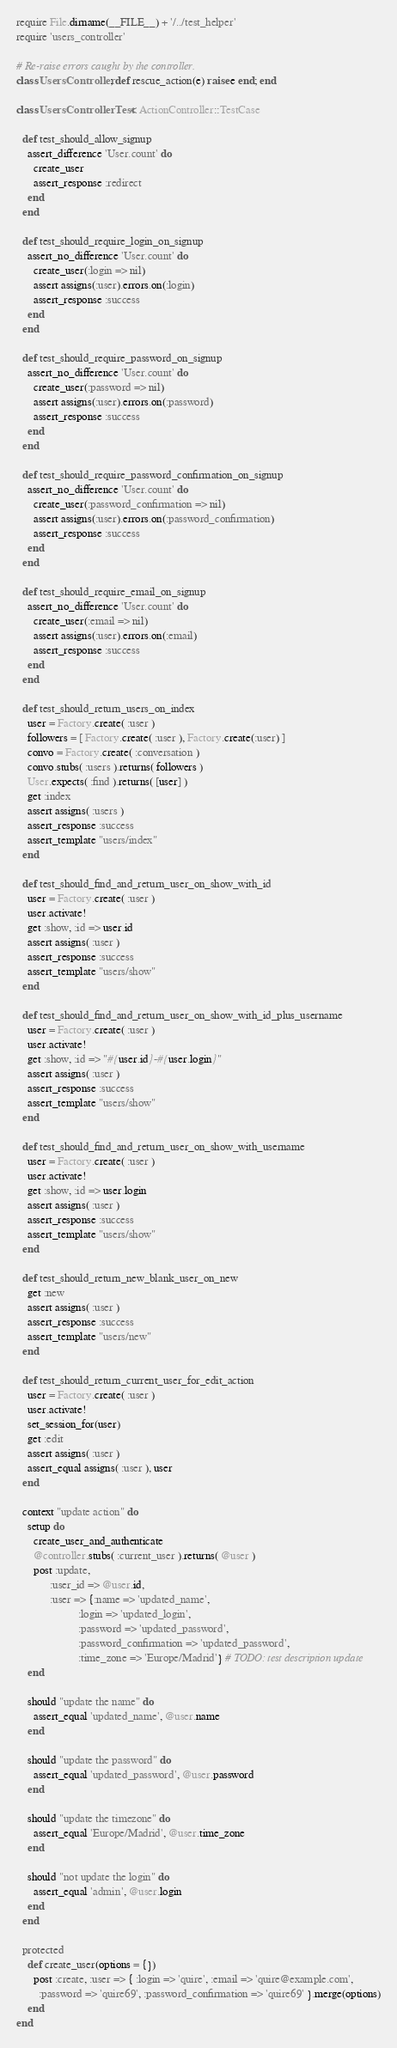Convert code to text. <code><loc_0><loc_0><loc_500><loc_500><_Ruby_>require File.dirname(__FILE__) + '/../test_helper'
require 'users_controller'

# Re-raise errors caught by the controller.
class UsersController; def rescue_action(e) raise e end; end

class UsersControllerTest < ActionController::TestCase

  def test_should_allow_signup
    assert_difference 'User.count' do
      create_user
      assert_response :redirect
    end
  end

  def test_should_require_login_on_signup
    assert_no_difference 'User.count' do
      create_user(:login => nil)
      assert assigns(:user).errors.on(:login)
      assert_response :success
    end
  end

  def test_should_require_password_on_signup
    assert_no_difference 'User.count' do
      create_user(:password => nil)
      assert assigns(:user).errors.on(:password)
      assert_response :success
    end
  end

  def test_should_require_password_confirmation_on_signup
    assert_no_difference 'User.count' do
      create_user(:password_confirmation => nil)
      assert assigns(:user).errors.on(:password_confirmation)
      assert_response :success
    end
  end

  def test_should_require_email_on_signup
    assert_no_difference 'User.count' do
      create_user(:email => nil)
      assert assigns(:user).errors.on(:email)
      assert_response :success
    end
  end
  
  def test_should_return_users_on_index
    user = Factory.create( :user )
    followers = [ Factory.create( :user ), Factory.create(:user) ]
    convo = Factory.create( :conversation )
    convo.stubs( :users ).returns( followers )
    User.expects( :find ).returns( [user] )
    get :index
    assert assigns( :users )
    assert_response :success
    assert_template "users/index"
  end 

  def test_should_find_and_return_user_on_show_with_id
    user = Factory.create( :user )
    user.activate!    
    get :show, :id => user.id
    assert assigns( :user )
    assert_response :success
    assert_template "users/show"
  end
  
  def test_should_find_and_return_user_on_show_with_id_plus_username
    user = Factory.create( :user )
    user.activate!    
    get :show, :id => "#{user.id}-#{user.login}"
    assert assigns( :user )
    assert_response :success
    assert_template "users/show"
  end
  
  def test_should_find_and_return_user_on_show_with_username
    user = Factory.create( :user )
    user.activate!    
    get :show, :id => user.login
    assert assigns( :user )
    assert_response :success
    assert_template "users/show"
  end
  
  def test_should_return_new_blank_user_on_new 
    get :new
    assert assigns( :user )
    assert_response :success
    assert_template "users/new"
  end

  def test_should_return_current_user_for_edit_action
    user = Factory.create( :user )
    user.activate!
    set_session_for(user)
    get :edit
    assert assigns( :user )
    assert_equal assigns( :user ), user
  end

  context "update action" do
    setup do
      create_user_and_authenticate
      @controller.stubs( :current_user ).returns( @user )
      post :update,
            :user_id => @user.id,
            :user => {:name => 'updated_name',
                      :login => 'updated_login',
                      :password => 'updated_password',
                      :password_confirmation => 'updated_password',
                      :time_zone => 'Europe/Madrid'} # TODO: test description update
    end
    
    should "update the name" do
      assert_equal 'updated_name', @user.name
    end
    
    should "update the password" do
      assert_equal 'updated_password', @user.password
    end
    
    should "update the timezone" do
      assert_equal 'Europe/Madrid', @user.time_zone
    end
    
    should "not update the login" do
      assert_equal 'admin', @user.login
    end
  end
  
  protected
    def create_user(options = {})
      post :create, :user => { :login => 'quire', :email => 'quire@example.com',
        :password => 'quire69', :password_confirmation => 'quire69' }.merge(options)
    end
end
</code> 